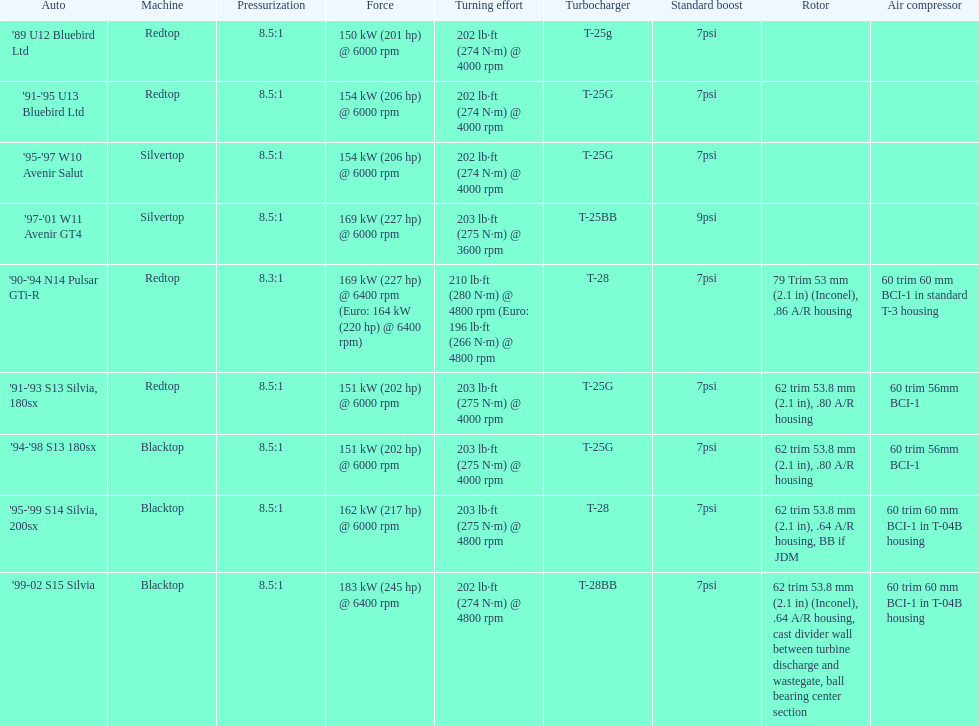What are all of the cars? '89 U12 Bluebird Ltd, '91-'95 U13 Bluebird Ltd, '95-'97 W10 Avenir Salut, '97-'01 W11 Avenir GT4, '90-'94 N14 Pulsar GTi-R, '91-'93 S13 Silvia, 180sx, '94-'98 S13 180sx, '95-'99 S14 Silvia, 200sx, '99-02 S15 Silvia. What is their rated power? 150 kW (201 hp) @ 6000 rpm, 154 kW (206 hp) @ 6000 rpm, 154 kW (206 hp) @ 6000 rpm, 169 kW (227 hp) @ 6000 rpm, 169 kW (227 hp) @ 6400 rpm (Euro: 164 kW (220 hp) @ 6400 rpm), 151 kW (202 hp) @ 6000 rpm, 151 kW (202 hp) @ 6000 rpm, 162 kW (217 hp) @ 6000 rpm, 183 kW (245 hp) @ 6400 rpm. Which car has the most power? '99-02 S15 Silvia. 